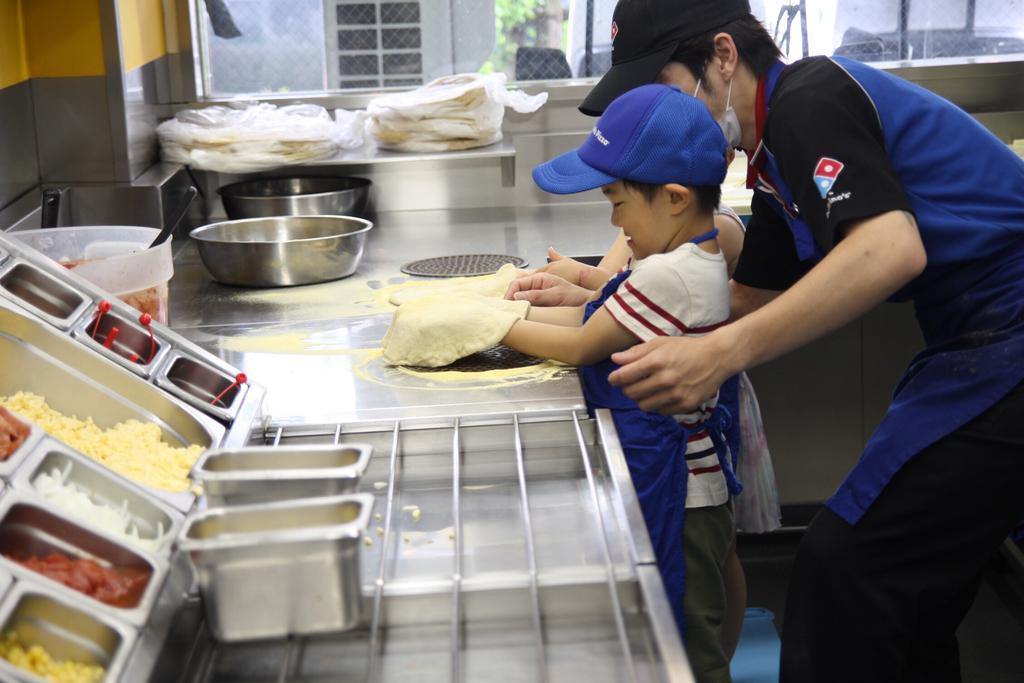Can you describe this image briefly? This image is taken inside a kitchen. There are two people standing at the right side of the image wearing a cap. 